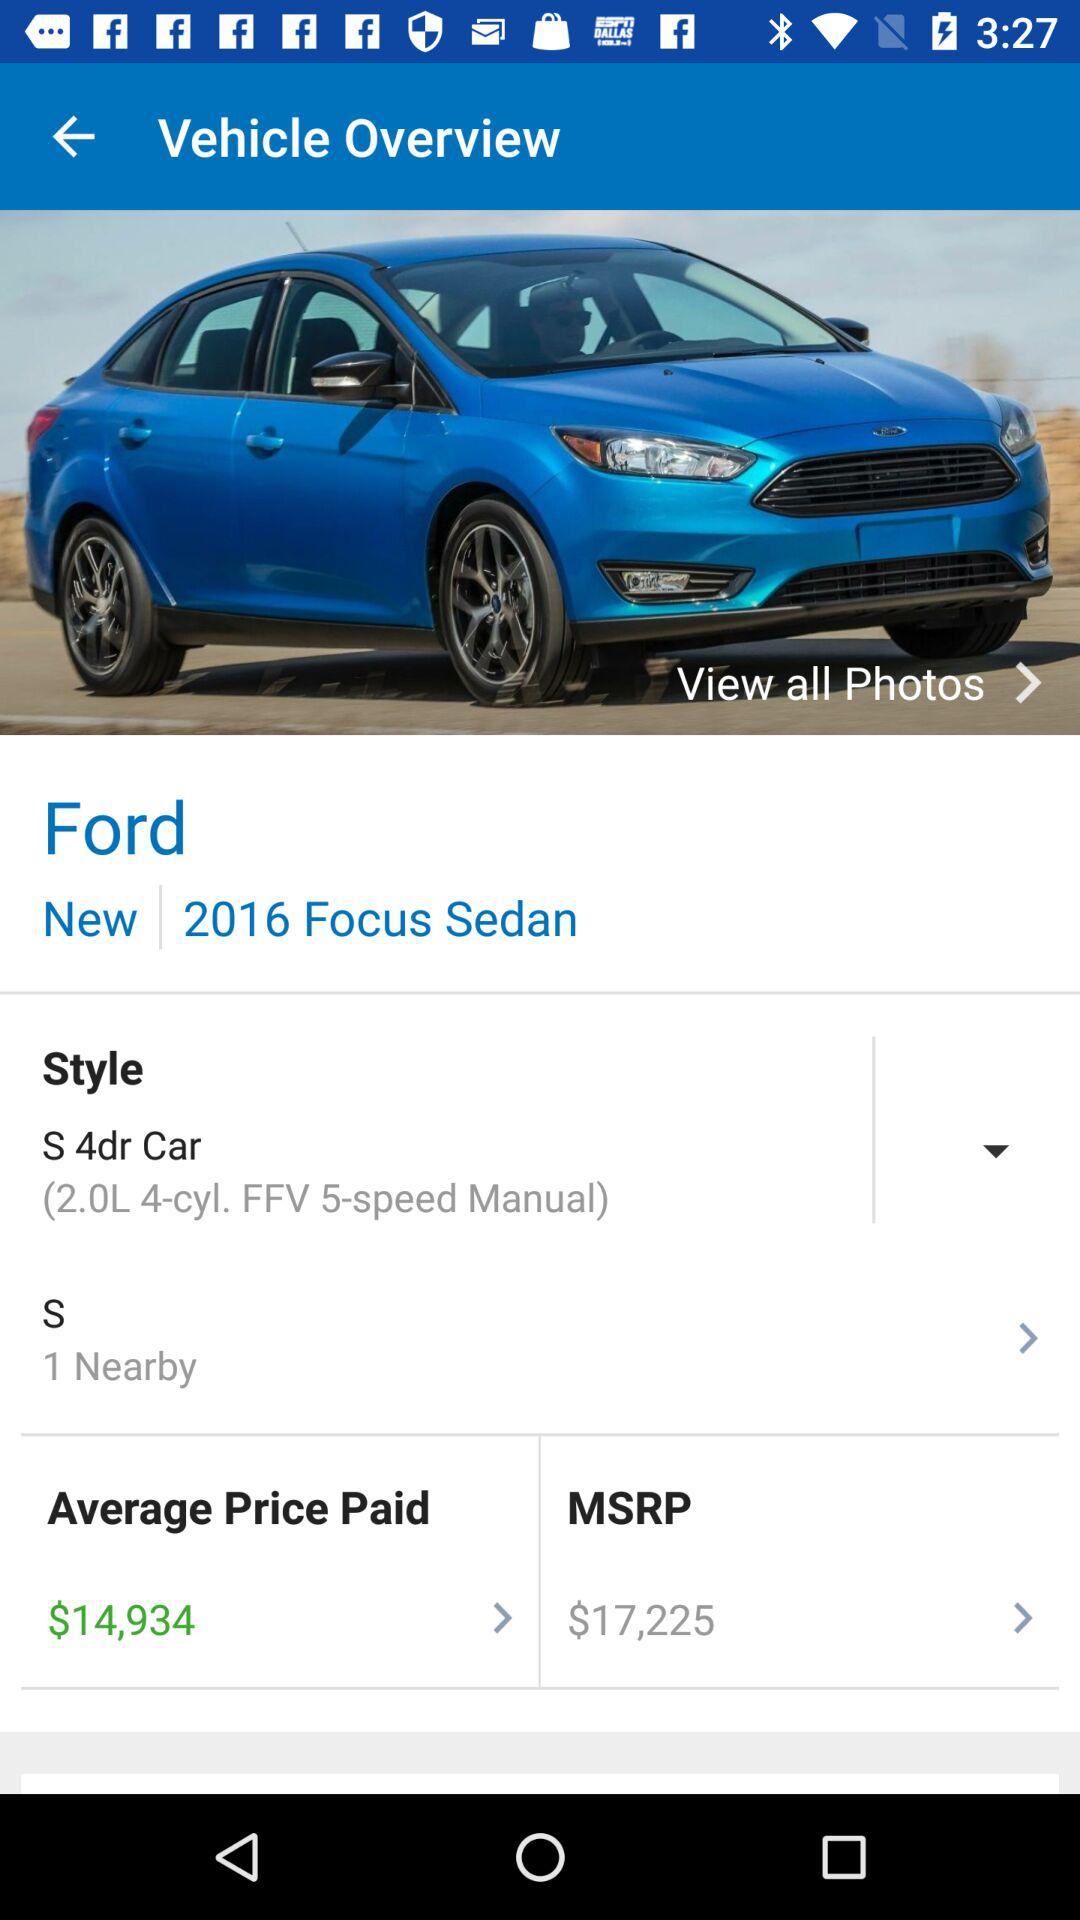How much more is the MSRP than the average price paid?
Answer the question using a single word or phrase. $2291 